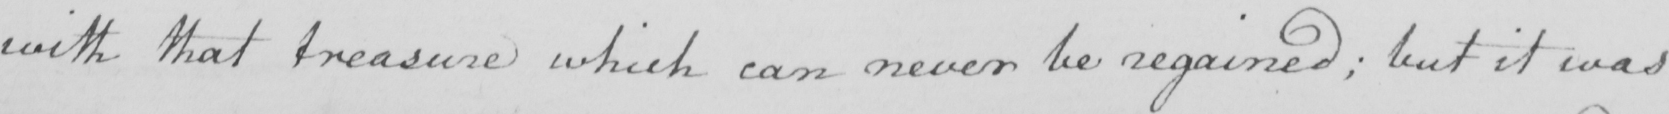Can you tell me what this handwritten text says? with that treasure which can never be regained ; but it was 